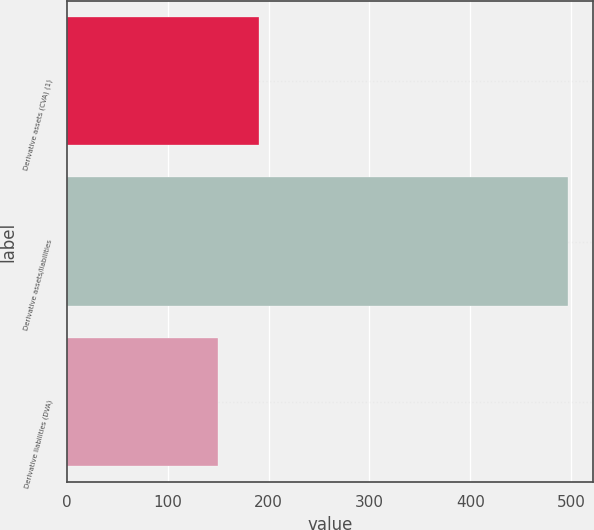Convert chart to OTSL. <chart><loc_0><loc_0><loc_500><loc_500><bar_chart><fcel>Derivative assets (CVA) (1)<fcel>Derivative assets/liabilities<fcel>Derivative liabilities (DVA)<nl><fcel>191<fcel>497<fcel>150<nl></chart> 